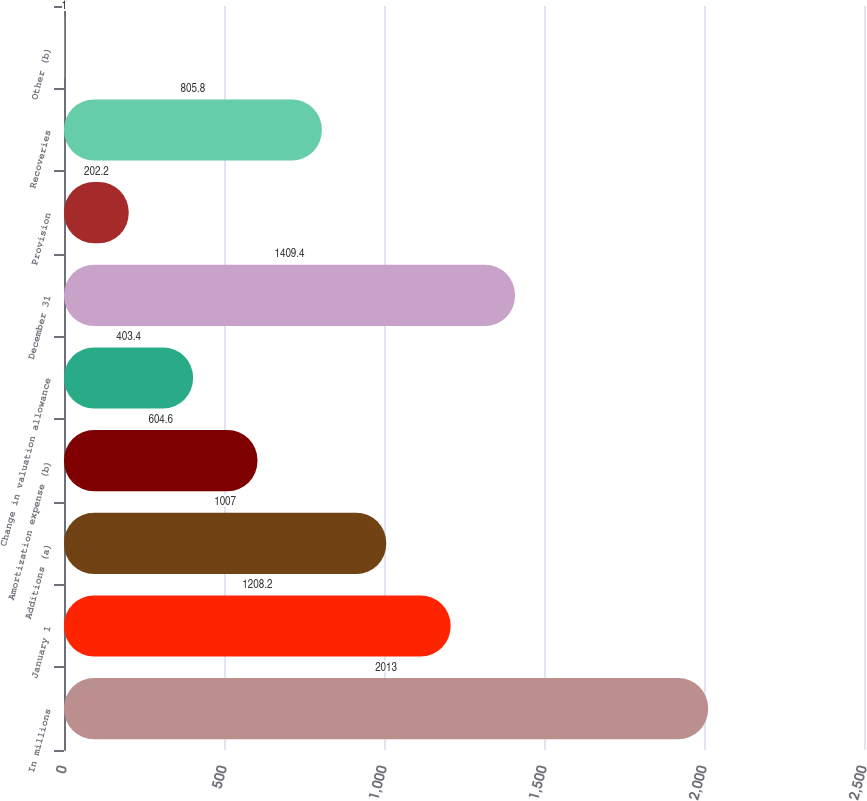Convert chart to OTSL. <chart><loc_0><loc_0><loc_500><loc_500><bar_chart><fcel>In millions<fcel>January 1<fcel>Additions (a)<fcel>Amortization expense (b)<fcel>Change in valuation allowance<fcel>December 31<fcel>Provision<fcel>Recoveries<fcel>Other (b)<nl><fcel>2013<fcel>1208.2<fcel>1007<fcel>604.6<fcel>403.4<fcel>1409.4<fcel>202.2<fcel>805.8<fcel>1<nl></chart> 